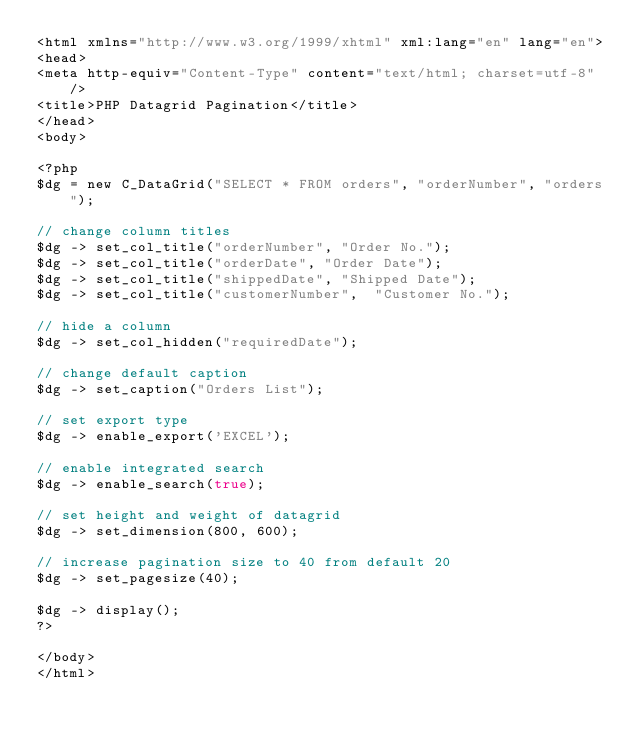<code> <loc_0><loc_0><loc_500><loc_500><_PHP_><html xmlns="http://www.w3.org/1999/xhtml" xml:lang="en" lang="en">
<head>
<meta http-equiv="Content-Type" content="text/html; charset=utf-8" />
<title>PHP Datagrid Pagination</title>
</head>
<body> 

<?php
$dg = new C_DataGrid("SELECT * FROM orders", "orderNumber", "orders");

// change column titles
$dg -> set_col_title("orderNumber", "Order No.");
$dg -> set_col_title("orderDate", "Order Date");
$dg -> set_col_title("shippedDate", "Shipped Date");
$dg -> set_col_title("customerNumber",  "Customer No.");

// hide a column
$dg -> set_col_hidden("requiredDate");

// change default caption
$dg -> set_caption("Orders List");

// set export type
$dg -> enable_export('EXCEL');

// enable integrated search
$dg -> enable_search(true);

// set height and weight of datagrid
$dg -> set_dimension(800, 600); 

// increase pagination size to 40 from default 20
$dg -> set_pagesize(40);

$dg -> display();
?>

</body>
</html></code> 